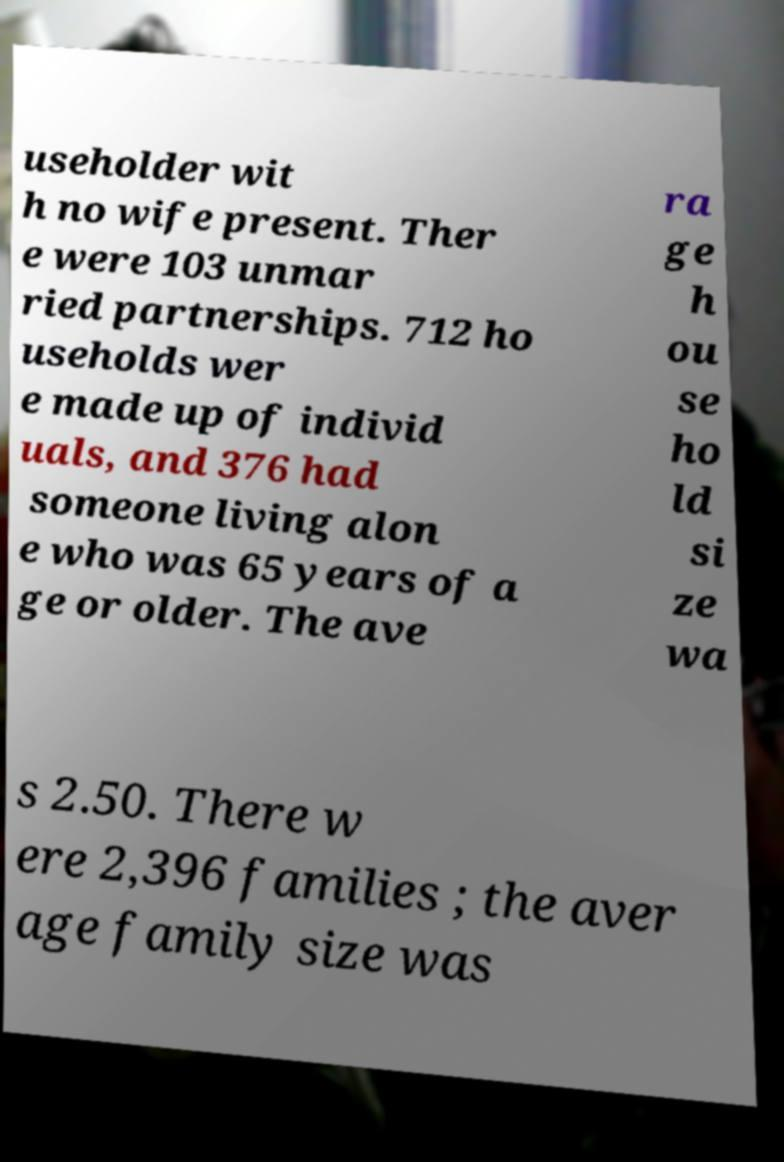Could you extract and type out the text from this image? useholder wit h no wife present. Ther e were 103 unmar ried partnerships. 712 ho useholds wer e made up of individ uals, and 376 had someone living alon e who was 65 years of a ge or older. The ave ra ge h ou se ho ld si ze wa s 2.50. There w ere 2,396 families ; the aver age family size was 